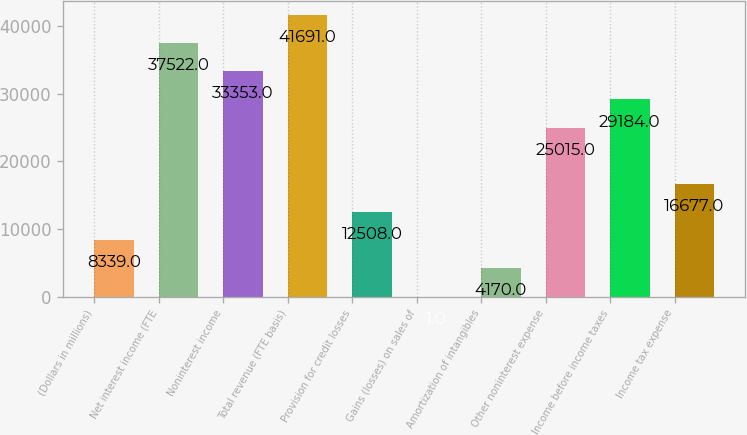Convert chart. <chart><loc_0><loc_0><loc_500><loc_500><bar_chart><fcel>(Dollars in millions)<fcel>Net interest income (FTE<fcel>Noninterest income<fcel>Total revenue (FTE basis)<fcel>Provision for credit losses<fcel>Gains (losses) on sales of<fcel>Amortization of intangibles<fcel>Other noninterest expense<fcel>Income before income taxes<fcel>Income tax expense<nl><fcel>8339<fcel>37522<fcel>33353<fcel>41691<fcel>12508<fcel>1<fcel>4170<fcel>25015<fcel>29184<fcel>16677<nl></chart> 